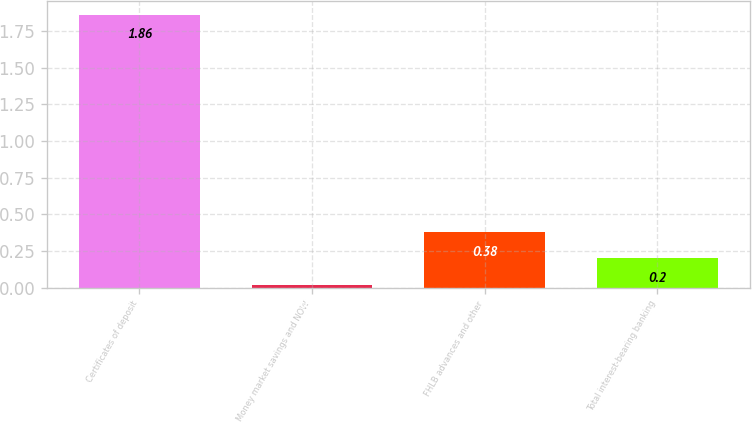Convert chart. <chart><loc_0><loc_0><loc_500><loc_500><bar_chart><fcel>Certificates of deposit<fcel>Money market savings and NOW<fcel>FHLB advances and other<fcel>Total interest-bearing banking<nl><fcel>1.86<fcel>0.02<fcel>0.38<fcel>0.2<nl></chart> 